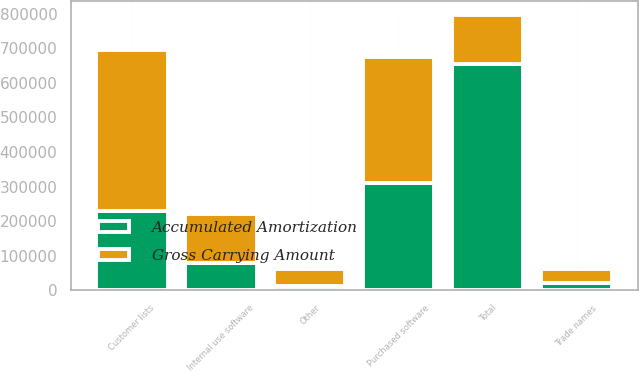<chart> <loc_0><loc_0><loc_500><loc_500><stacked_bar_chart><ecel><fcel>Customer lists<fcel>Purchased software<fcel>Internal use software<fcel>Trade names<fcel>Other<fcel>Total<nl><fcel>Gross Carrying Amount<fcel>465909<fcel>361964<fcel>143520<fcel>40025<fcel>47905<fcel>143520<nl><fcel>Accumulated Amortization<fcel>229545<fcel>311738<fcel>78633<fcel>21275<fcel>12827<fcel>654018<nl></chart> 